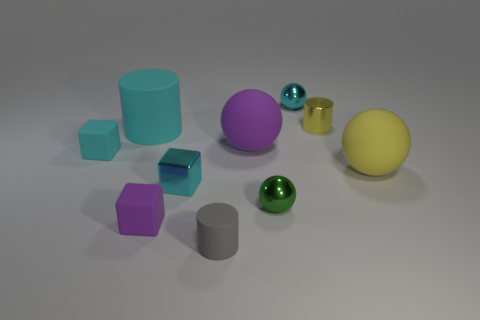Subtract all yellow balls. How many balls are left? 3 Subtract all blocks. How many objects are left? 7 Add 5 small purple things. How many small purple things exist? 6 Subtract all purple spheres. How many spheres are left? 3 Subtract 0 purple cylinders. How many objects are left? 10 Subtract 3 cubes. How many cubes are left? 0 Subtract all cyan cylinders. Subtract all brown balls. How many cylinders are left? 2 Subtract all cyan cylinders. How many yellow spheres are left? 1 Subtract all small metallic cylinders. Subtract all purple rubber cubes. How many objects are left? 8 Add 6 cyan rubber cubes. How many cyan rubber cubes are left? 7 